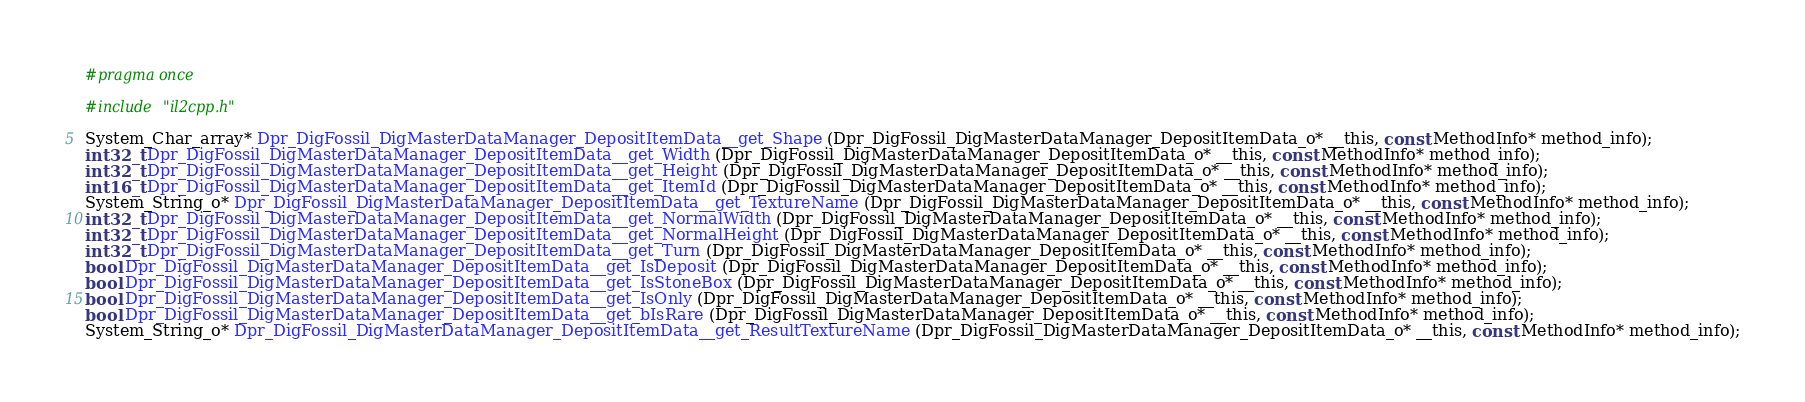Convert code to text. <code><loc_0><loc_0><loc_500><loc_500><_C_>#pragma once

#include "il2cpp.h"

System_Char_array* Dpr_DigFossil_DigMasterDataManager_DepositItemData__get_Shape (Dpr_DigFossil_DigMasterDataManager_DepositItemData_o* __this, const MethodInfo* method_info);
int32_t Dpr_DigFossil_DigMasterDataManager_DepositItemData__get_Width (Dpr_DigFossil_DigMasterDataManager_DepositItemData_o* __this, const MethodInfo* method_info);
int32_t Dpr_DigFossil_DigMasterDataManager_DepositItemData__get_Height (Dpr_DigFossil_DigMasterDataManager_DepositItemData_o* __this, const MethodInfo* method_info);
int16_t Dpr_DigFossil_DigMasterDataManager_DepositItemData__get_ItemId (Dpr_DigFossil_DigMasterDataManager_DepositItemData_o* __this, const MethodInfo* method_info);
System_String_o* Dpr_DigFossil_DigMasterDataManager_DepositItemData__get_TextureName (Dpr_DigFossil_DigMasterDataManager_DepositItemData_o* __this, const MethodInfo* method_info);
int32_t Dpr_DigFossil_DigMasterDataManager_DepositItemData__get_NormalWidth (Dpr_DigFossil_DigMasterDataManager_DepositItemData_o* __this, const MethodInfo* method_info);
int32_t Dpr_DigFossil_DigMasterDataManager_DepositItemData__get_NormalHeight (Dpr_DigFossil_DigMasterDataManager_DepositItemData_o* __this, const MethodInfo* method_info);
int32_t Dpr_DigFossil_DigMasterDataManager_DepositItemData__get_Turn (Dpr_DigFossil_DigMasterDataManager_DepositItemData_o* __this, const MethodInfo* method_info);
bool Dpr_DigFossil_DigMasterDataManager_DepositItemData__get_IsDeposit (Dpr_DigFossil_DigMasterDataManager_DepositItemData_o* __this, const MethodInfo* method_info);
bool Dpr_DigFossil_DigMasterDataManager_DepositItemData__get_IsStoneBox (Dpr_DigFossil_DigMasterDataManager_DepositItemData_o* __this, const MethodInfo* method_info);
bool Dpr_DigFossil_DigMasterDataManager_DepositItemData__get_IsOnly (Dpr_DigFossil_DigMasterDataManager_DepositItemData_o* __this, const MethodInfo* method_info);
bool Dpr_DigFossil_DigMasterDataManager_DepositItemData__get_bIsRare (Dpr_DigFossil_DigMasterDataManager_DepositItemData_o* __this, const MethodInfo* method_info);
System_String_o* Dpr_DigFossil_DigMasterDataManager_DepositItemData__get_ResultTextureName (Dpr_DigFossil_DigMasterDataManager_DepositItemData_o* __this, const MethodInfo* method_info);</code> 